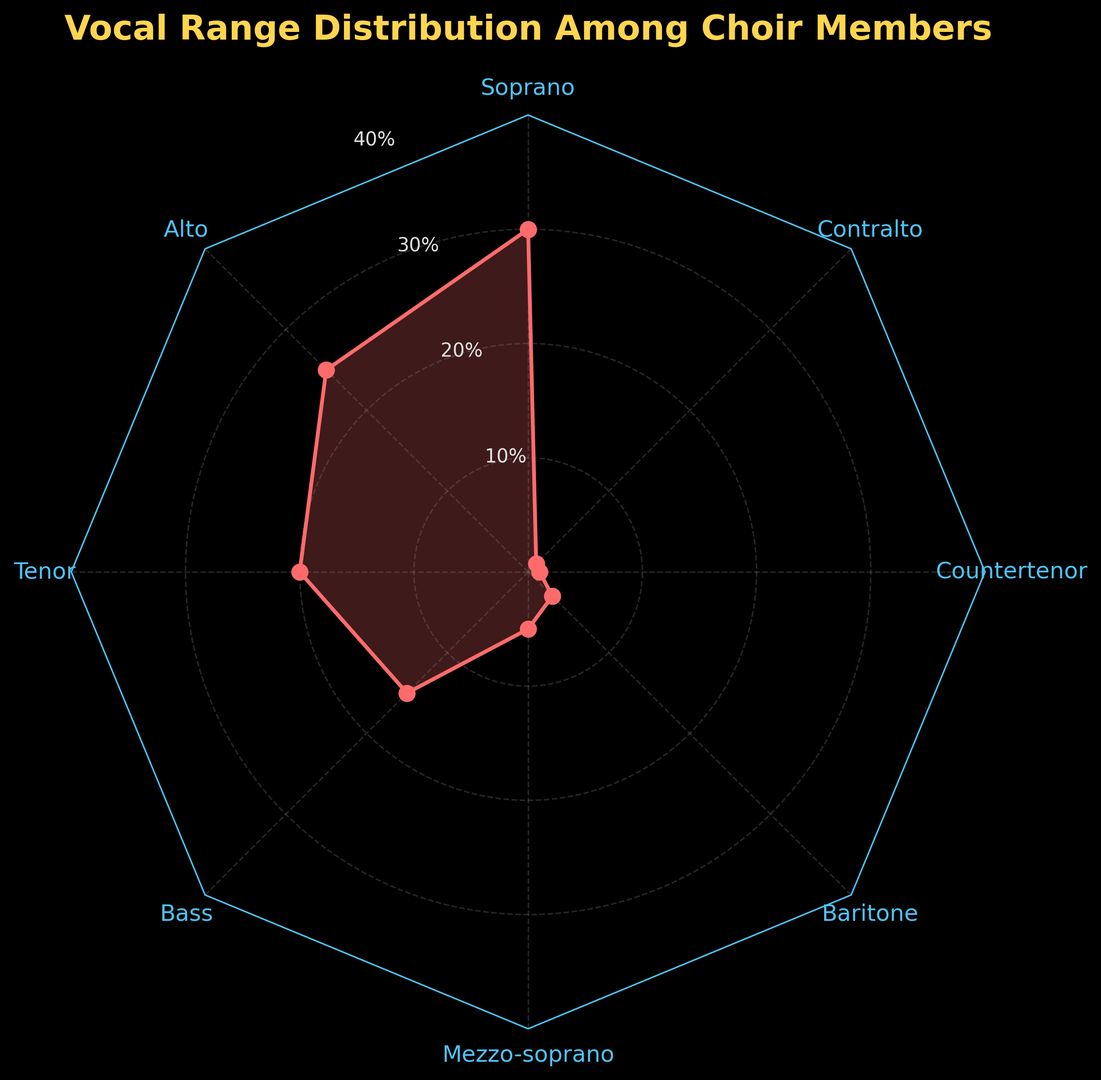What's the category with the highest percentage? Look at the radar chart and observe which vocal range category has the longest line from the center of the chart. This means it has the highest percentage.
Answer: Soprano Which category has the lowest percentage? Find the vocal range category with the shortest line from the center of the chart. This signifies the lowest percentage.
Answer: Countertenor and Contralto How many categories have a percentage greater than 20%? Identify and count the categories that have a line extending beyond the 20% mark on the radar chart. There are three such categories: Soprano, Alto, and Tenor.
Answer: 3 What's the combined percentage of Soprano and Alto? Look at the percentage values for Soprano and Alto in the radar chart: Soprano is 30% and Alto is 25%. Add these values together.
Answer: 55% How much more percentage does Soprano have compared to Bass? Find the percentage for both Soprano and Bass from the chart (Soprano is 30% and Bass is 15%). Subtract the Bass percentage from the Soprano percentage.
Answer: 15% What is the average percentage of Alto, Tenor, and Bass categories? Look at the radar chart and find the percentages for Alto (25%), Tenor (20%), and Bass (15%). Add these values and divide by 3 to find the average. (25 + 20 + 15) / 3 = 20
Answer: 20% What percentage range do most of the categories fall within? Observe the radar chart and see the distribution of the percentages. Notice that most categories have percentages between 1% and 30%. The majority cluster around 1% to 25%.
Answer: 1% to 30% Is the percentage of Tenor closer to Alto or Bass? Compare the percentage values: Tenor is 20%, Alto is 25%, and Bass is 15%. The difference between Tenor and Alto is 5%, and the difference between Tenor and Bass is also 5%. Therefore, Tenor is equally distant from both Alto and Bass.
Answer: Equidistant from both Alto and Bass What is the total percentage for categories with less than 10%? Identify categories with less than 10%: Mezzo-soprano (5%), Baritone (3%), Countertenor (1%), and Contralto (1%). Add these percentages together. 5 + 3 + 1 + 1 = 10%
Answer: 10% Which category is closest to the average percentage of all categories? Calculate the average percentage: Sum all percentages (30 + 25 + 20 + 15 + 5 + 3 + 1 + 1 = 100) and divide by the number of categories (8). The average is 100 / 8 = 12.5%. The category closest to this value is Bass, which is 15%.
Answer: Bass 